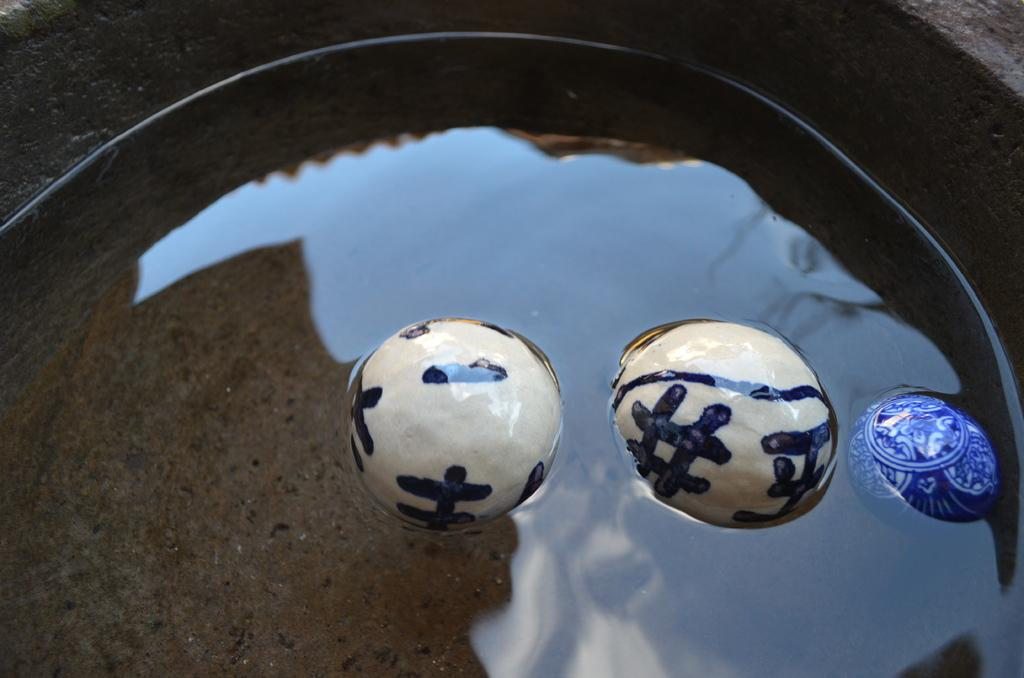What is in the water in the image? There are balls in the water. What can be seen at the top of the image? The top of the image contains a wall from left to right. What visual effect can be observed on the water's surface? There are reflections visible on the water. Can you hear the yak's horn in the image? There is no yak or horn present in the image. What type of error can be seen in the image? There is no error visible in the image; it appears to be a clear and accurate representation of the scene. 